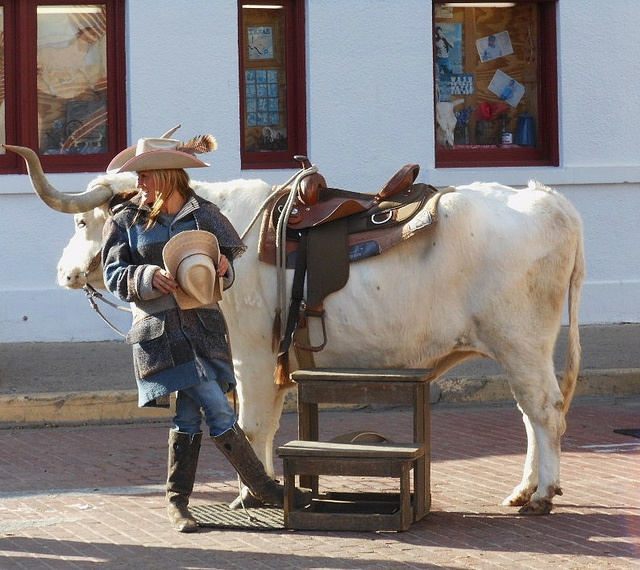Describe the objects in this image and their specific colors. I can see cow in maroon, darkgray, gray, and lightgray tones and people in maroon, black, gray, and darkgray tones in this image. 